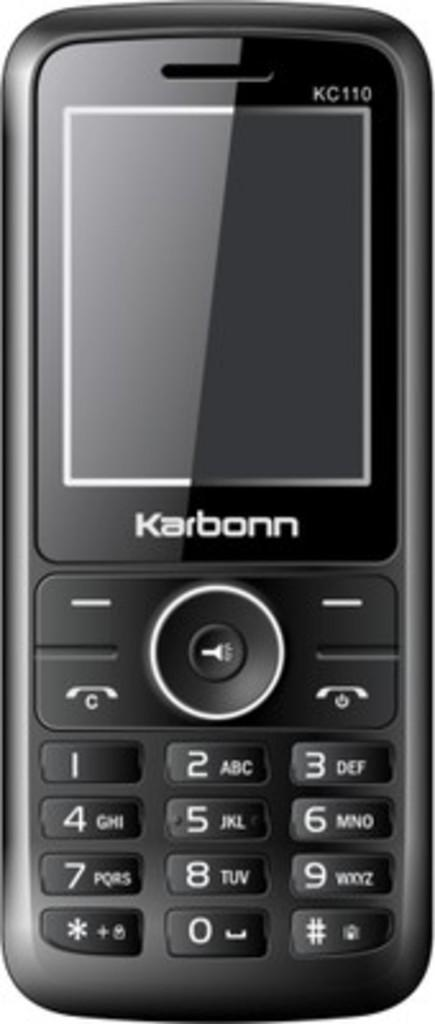<image>
Give a short and clear explanation of the subsequent image. An old style phone with the word Karbonn on it. 